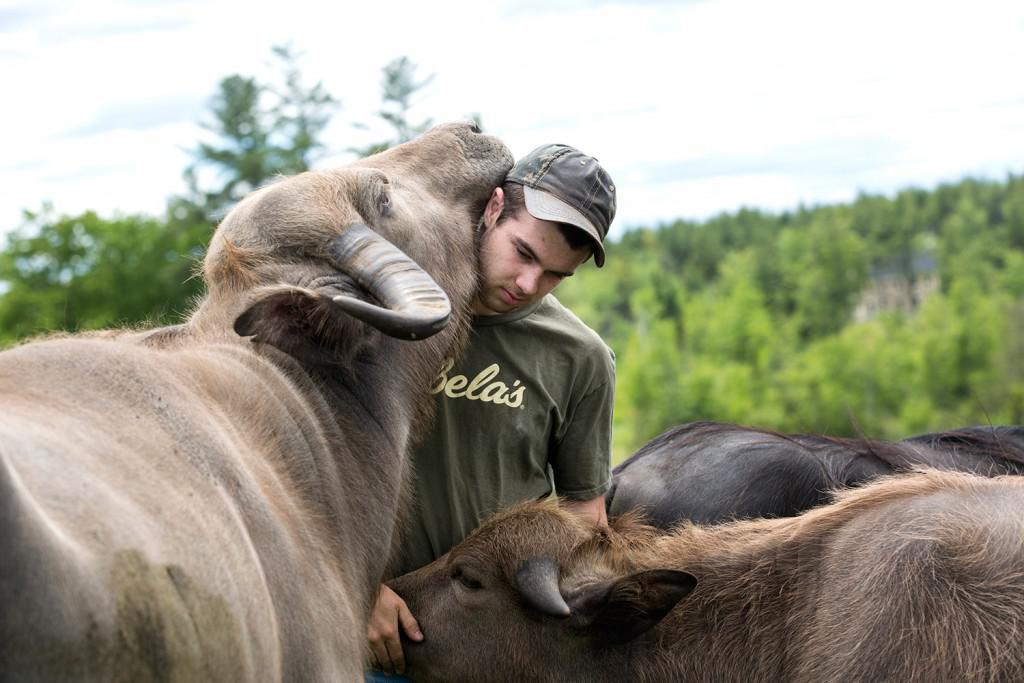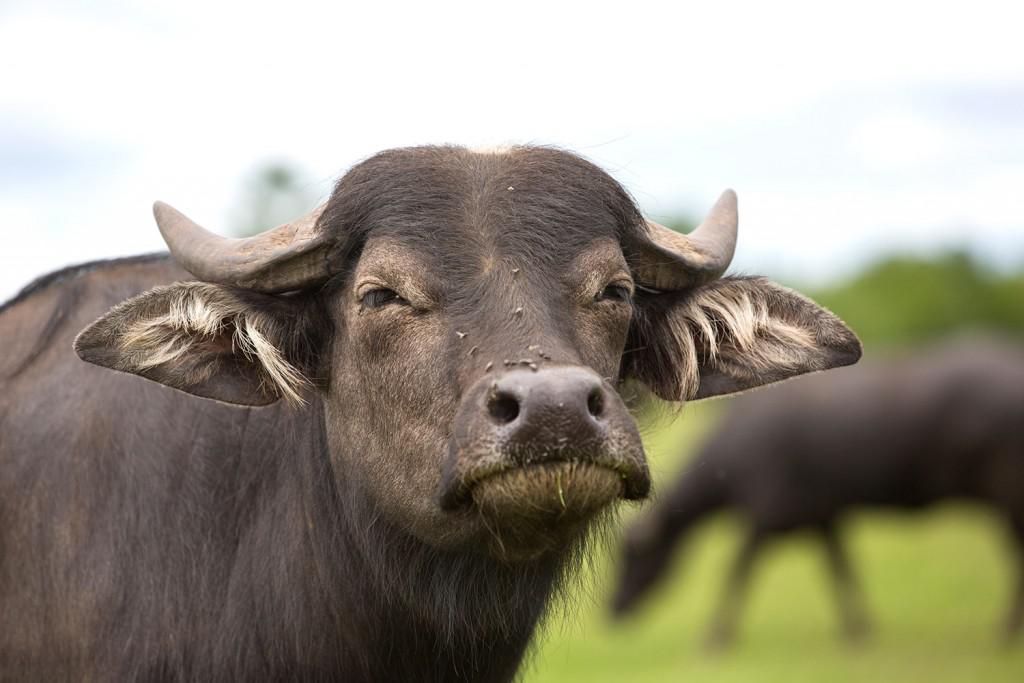The first image is the image on the left, the second image is the image on the right. For the images displayed, is the sentence "In each image, there is at least one cow looking directly at the camera." factually correct? Answer yes or no. No. The first image is the image on the left, the second image is the image on the right. Given the left and right images, does the statement "Each image includes a water buffalo with its face mostly forward." hold true? Answer yes or no. No. 